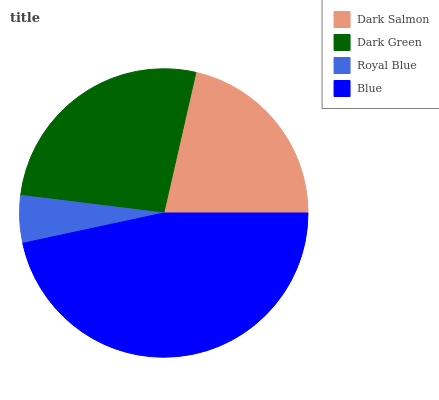Is Royal Blue the minimum?
Answer yes or no. Yes. Is Blue the maximum?
Answer yes or no. Yes. Is Dark Green the minimum?
Answer yes or no. No. Is Dark Green the maximum?
Answer yes or no. No. Is Dark Green greater than Dark Salmon?
Answer yes or no. Yes. Is Dark Salmon less than Dark Green?
Answer yes or no. Yes. Is Dark Salmon greater than Dark Green?
Answer yes or no. No. Is Dark Green less than Dark Salmon?
Answer yes or no. No. Is Dark Green the high median?
Answer yes or no. Yes. Is Dark Salmon the low median?
Answer yes or no. Yes. Is Blue the high median?
Answer yes or no. No. Is Royal Blue the low median?
Answer yes or no. No. 